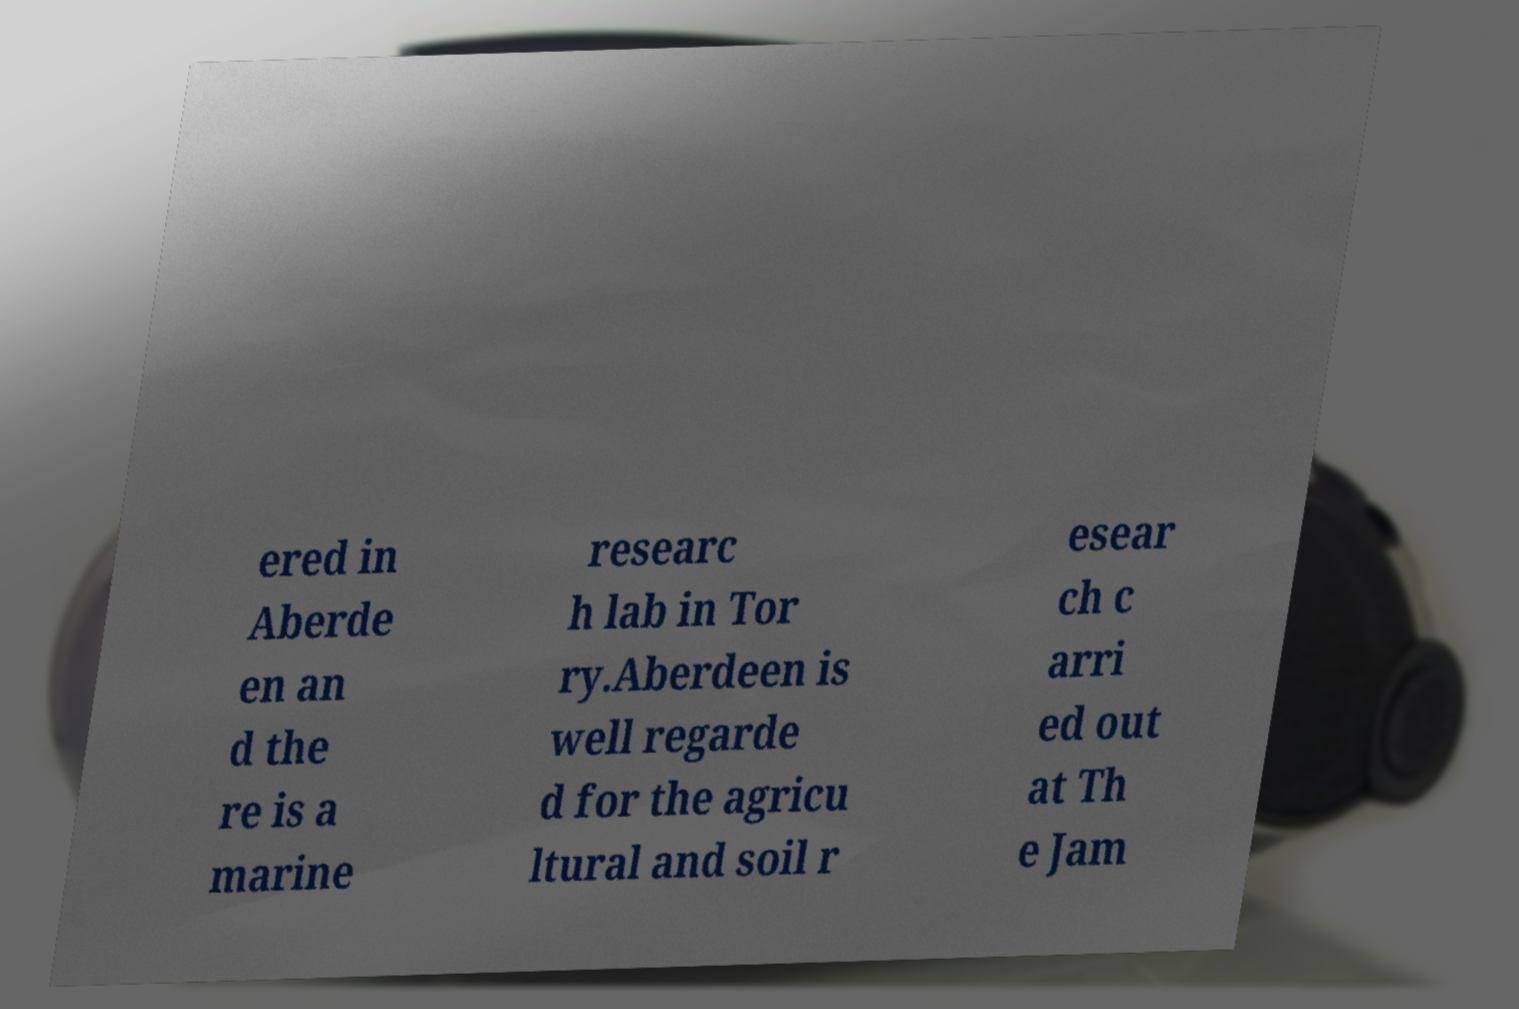Could you assist in decoding the text presented in this image and type it out clearly? ered in Aberde en an d the re is a marine researc h lab in Tor ry.Aberdeen is well regarde d for the agricu ltural and soil r esear ch c arri ed out at Th e Jam 